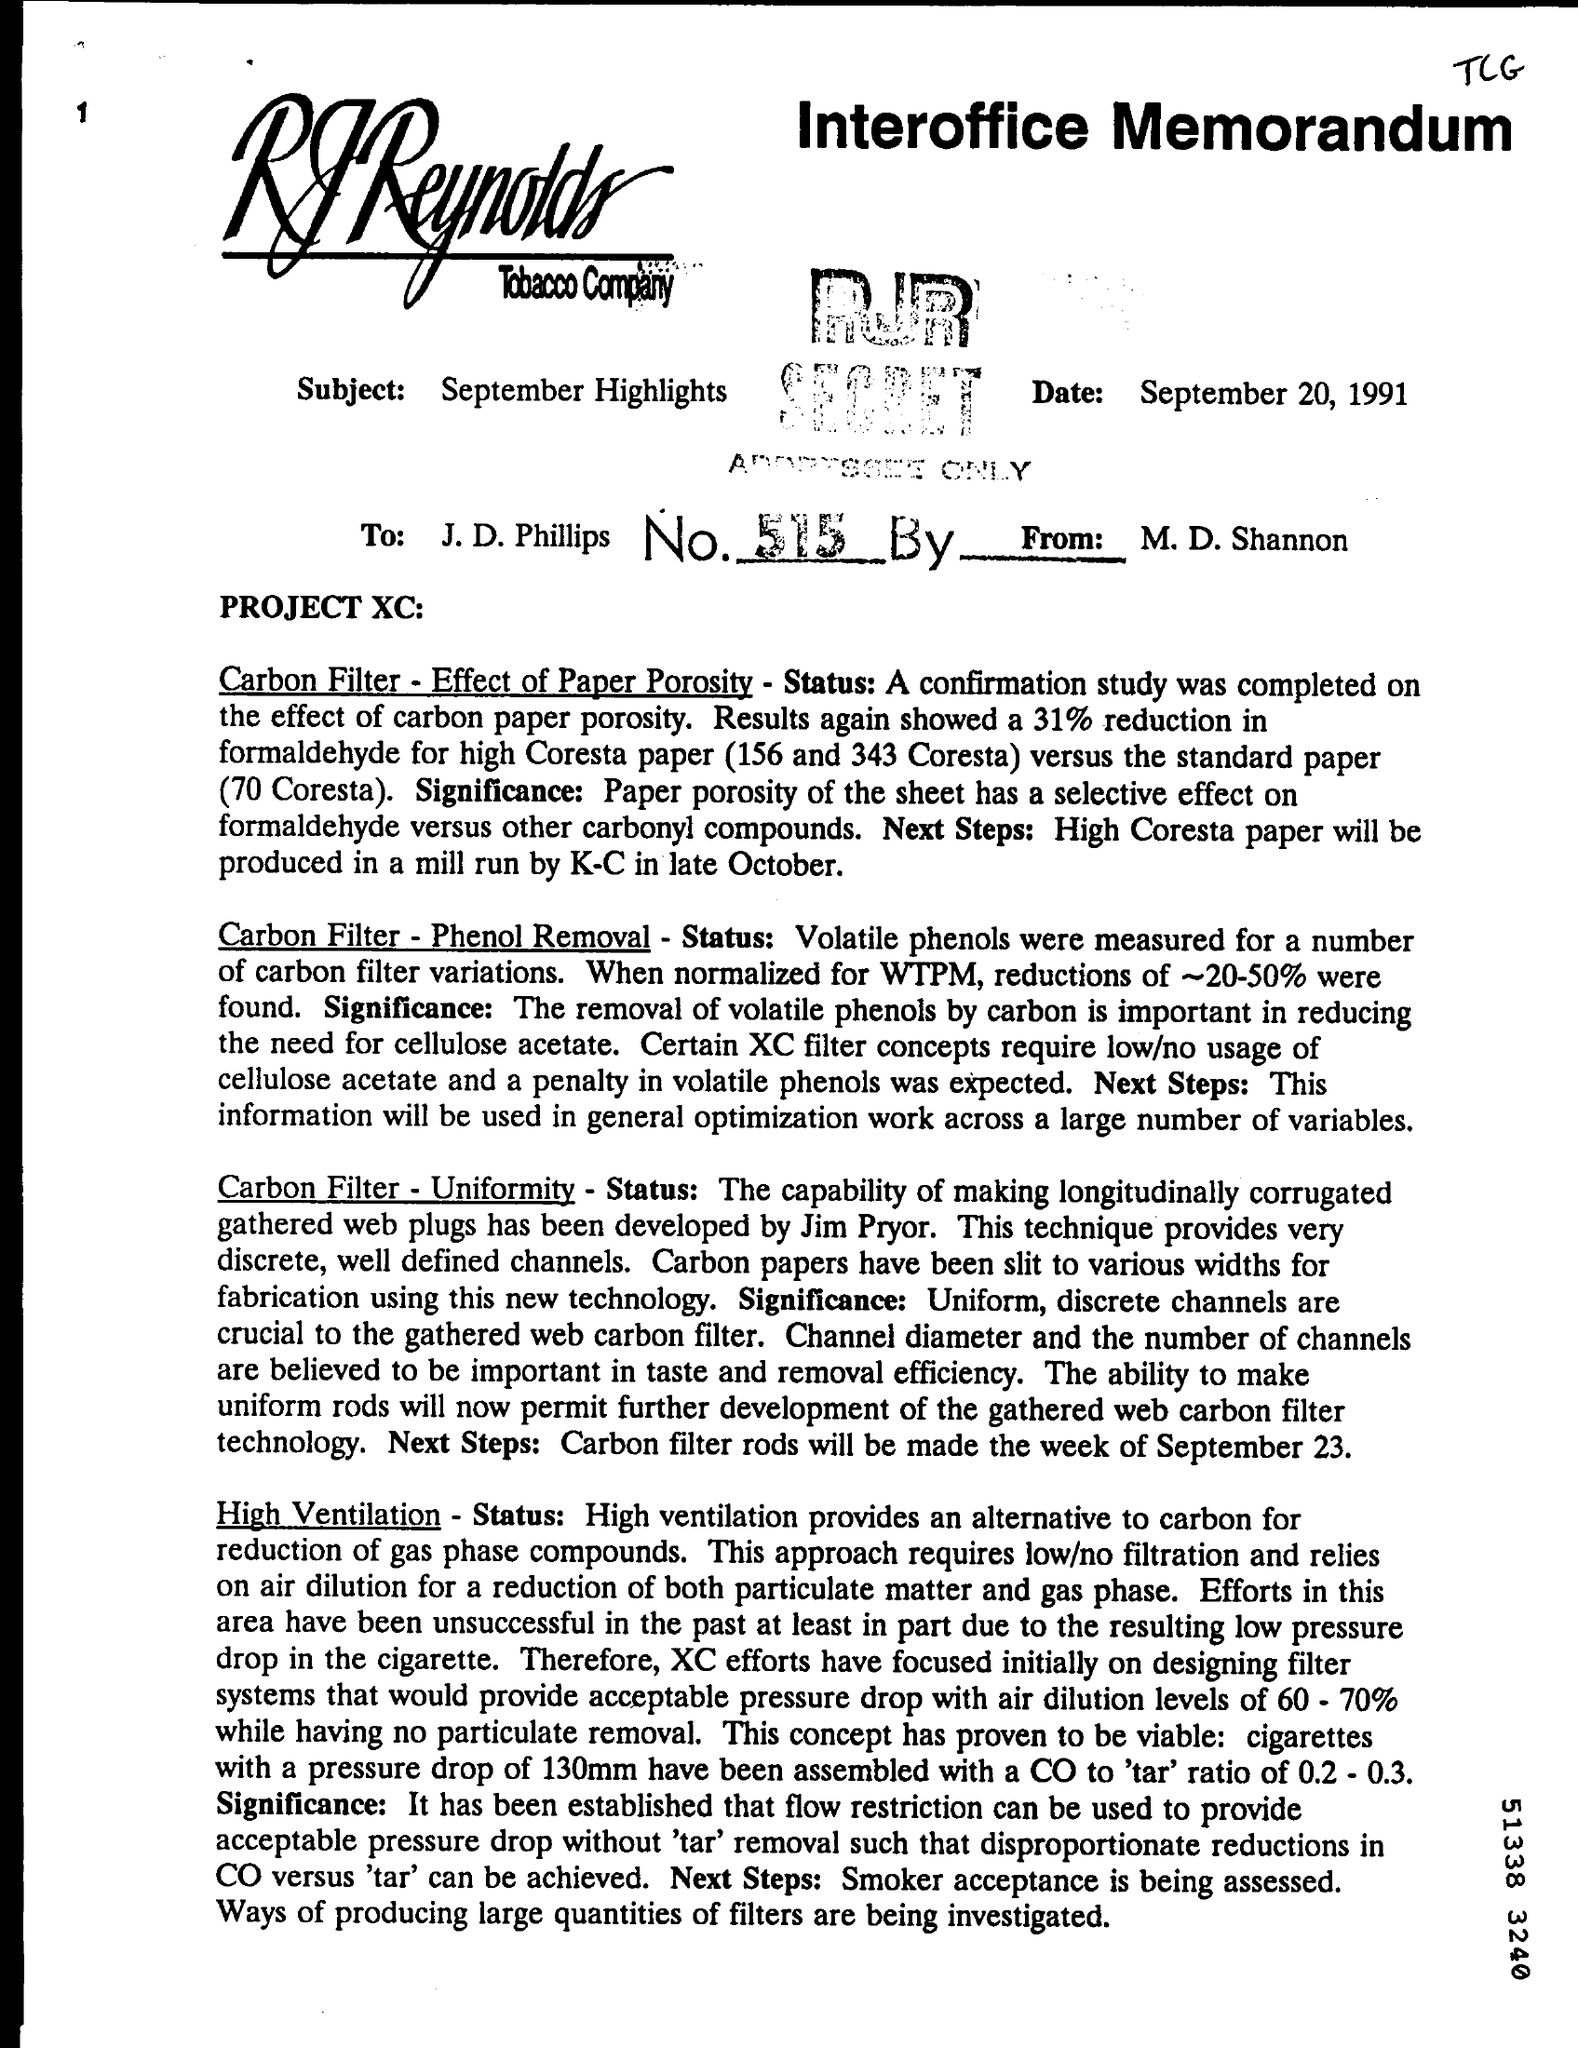When is the document dated?
Give a very brief answer. September 20, 1991. What is the subject of the document?
Keep it short and to the point. September Highlights. 